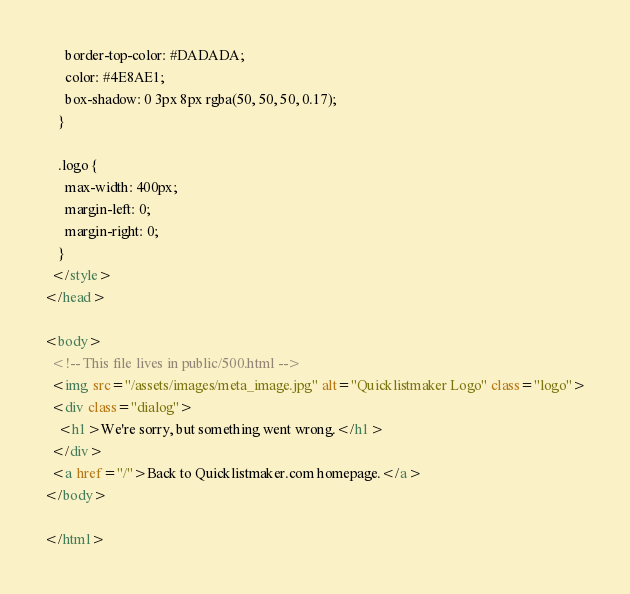Convert code to text. <code><loc_0><loc_0><loc_500><loc_500><_HTML_>      border-top-color: #DADADA;
      color: #4E8AE1;
      box-shadow: 0 3px 8px rgba(50, 50, 50, 0.17);
    }

    .logo {
      max-width: 400px;
      margin-left: 0;
      margin-right: 0;
    }
  </style>
</head>

<body>
  <!-- This file lives in public/500.html -->
  <img src="/assets/images/meta_image.jpg" alt="Quicklistmaker Logo" class="logo">
  <div class="dialog">
    <h1>We're sorry, but something went wrong.</h1>
  </div>
  <a href="/">Back to Quicklistmaker.com homepage.</a>
</body>

</html></code> 